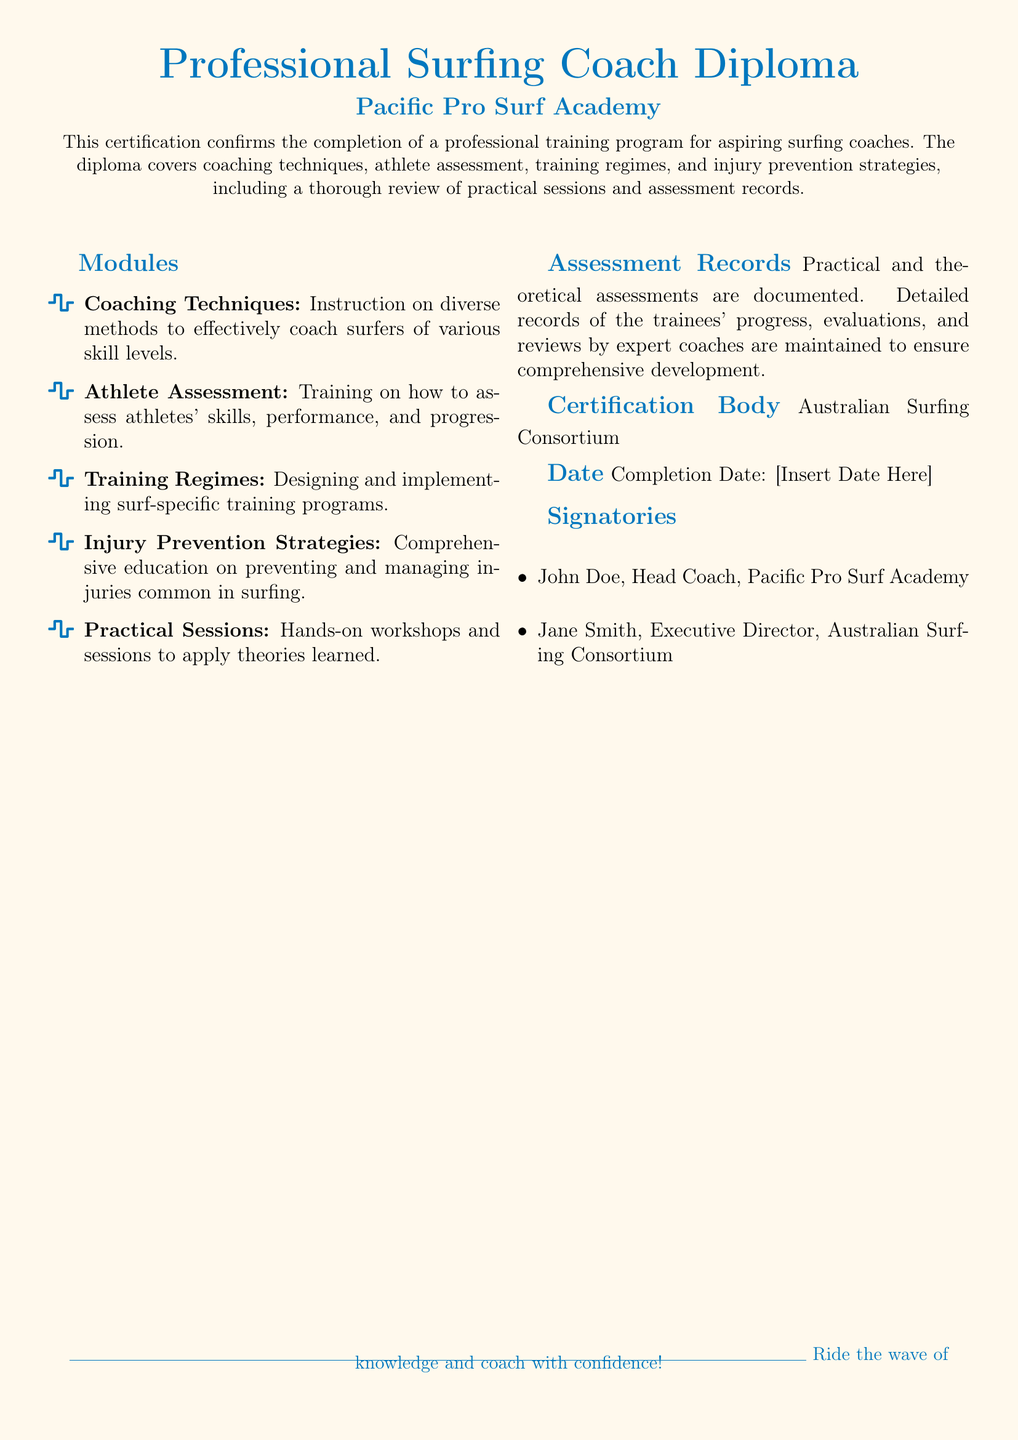What is the name of the certification? The document specifically refers to the certification as the "Professional Surfing Coach Diploma."
Answer: Professional Surfing Coach Diploma Who issued the diploma? The certification body indicated in the document is "Australian Surfing Consortium."
Answer: Australian Surfing Consortium What is the completion date label in the document? The document has a placeholder for the date of completion labeled as "Completion Date."
Answer: Completion Date What module focuses on injury management? The module addressing injuries is titled "Injury Prevention Strategies."
Answer: Injury Prevention Strategies How many modules are listed in the document? There are a total of five modules listed under the "Modules" section.
Answer: Five Who is the head coach associated with the diploma? The document mentions John Doe as the Head Coach of the Pacific Pro Surf Academy.
Answer: John Doe What does the diploma cover in terms of athlete evaluation? The document indicates that it covers "Athlete Assessment."
Answer: Athlete Assessment Which section lists the practical aspects of training? The section titled "Practical Sessions" details the hands-on workshops and sessions included.
Answer: Practical Sessions What is emphasized at the end of the document? The concluding message of the document encourages readers to "Ride the wave of knowledge and coach with confidence!"
Answer: Ride the wave of knowledge and coach with confidence! 